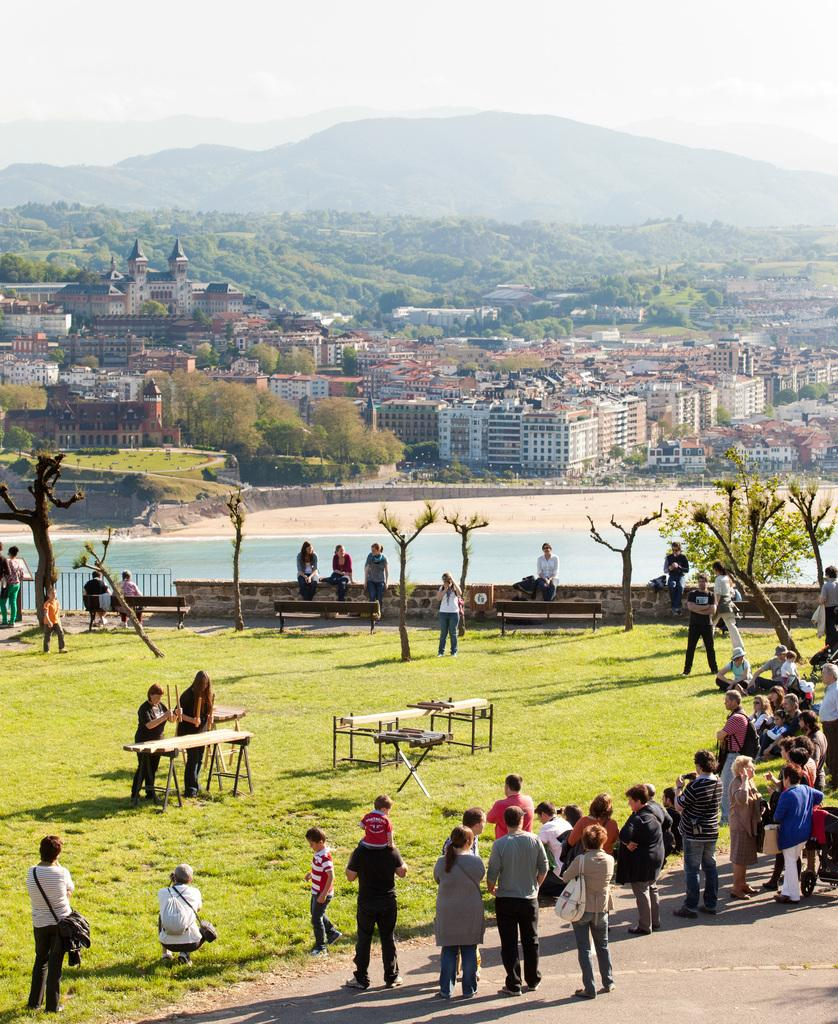What are the people in the image doing? Some people are standing, and others are sitting in the image. What objects can be seen in the image? There are tables in the image. What can be seen in the background of the image? There are trees and buildings in the background of the image. What natural element is visible in the image? Water is visible in the image. What type of paint is being used by the people in the image? There is no paint or painting activity depicted in the image. Can you tell me how many railway tracks are visible in the image? There are no railway tracks present in the image. 